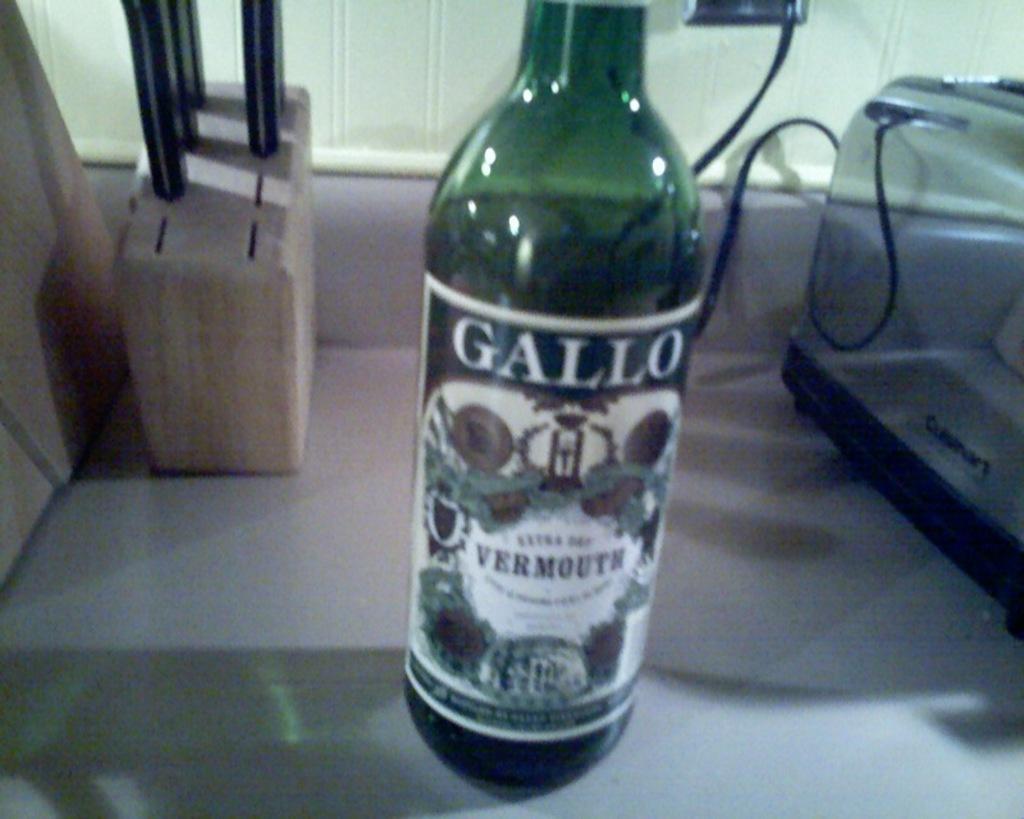What type of liquor is in this bottle?
Offer a terse response. Vermouth. What is the brand?
Your answer should be very brief. Gallo. 